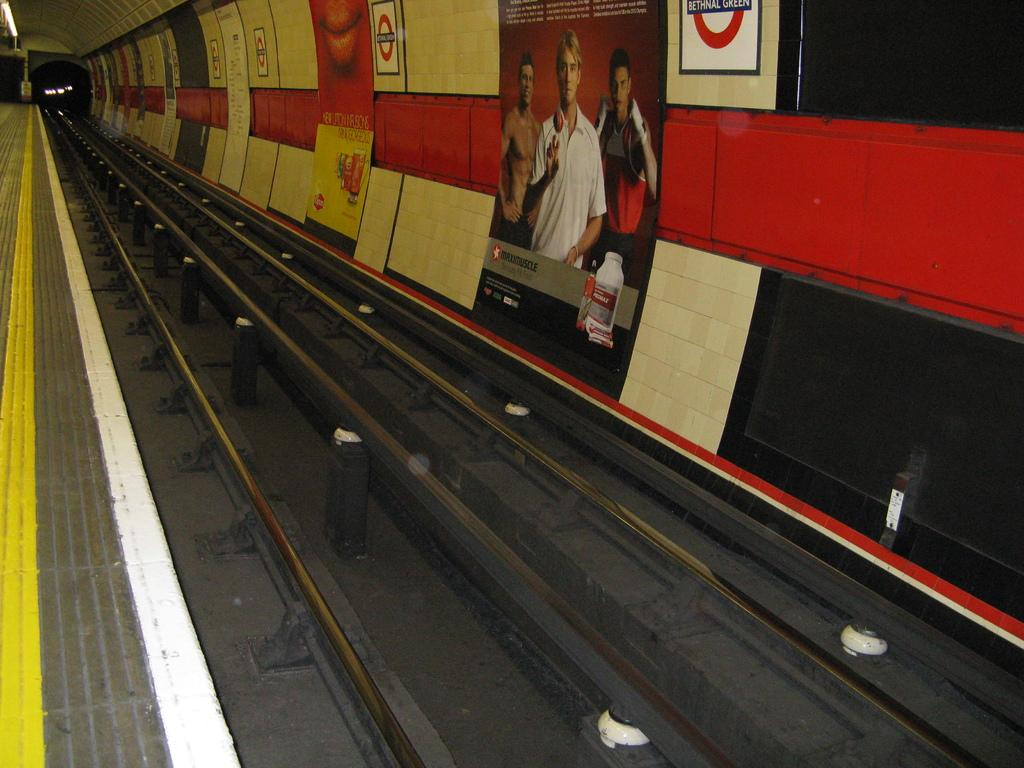What can be seen running through the image? There is a train track in the image. What is on the wall in the image? There are posters on the wall in the image. What type of caption is written on the lettuce in the image? There is no lettuce present in the image, so there is no caption to be read. 